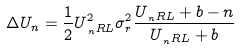<formula> <loc_0><loc_0><loc_500><loc_500>\Delta U _ { n } = \frac { 1 } { 2 } U _ { \, _ { n } { R L } } ^ { 2 } \sigma _ { r } ^ { 2 } \frac { U _ { \, _ { n } { R L } } + b - n } { U _ { \, _ { n } { R L } } + b }</formula> 